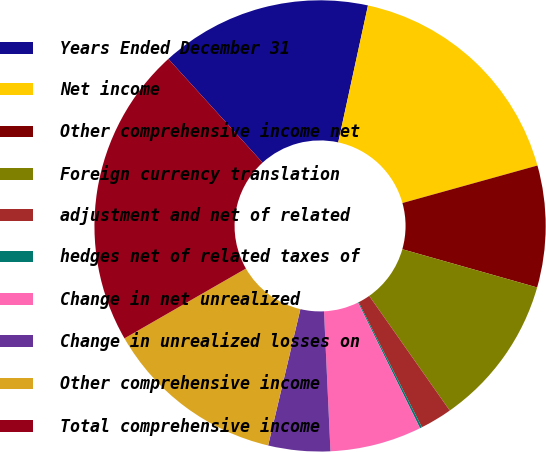<chart> <loc_0><loc_0><loc_500><loc_500><pie_chart><fcel>Years Ended December 31<fcel>Net income<fcel>Other comprehensive income net<fcel>Foreign currency translation<fcel>adjustment and net of related<fcel>hedges net of related taxes of<fcel>Change in net unrealized<fcel>Change in unrealized losses on<fcel>Other comprehensive income<fcel>Total comprehensive income<nl><fcel>15.14%<fcel>17.28%<fcel>8.71%<fcel>10.86%<fcel>2.29%<fcel>0.15%<fcel>6.57%<fcel>4.43%<fcel>13.0%<fcel>21.57%<nl></chart> 